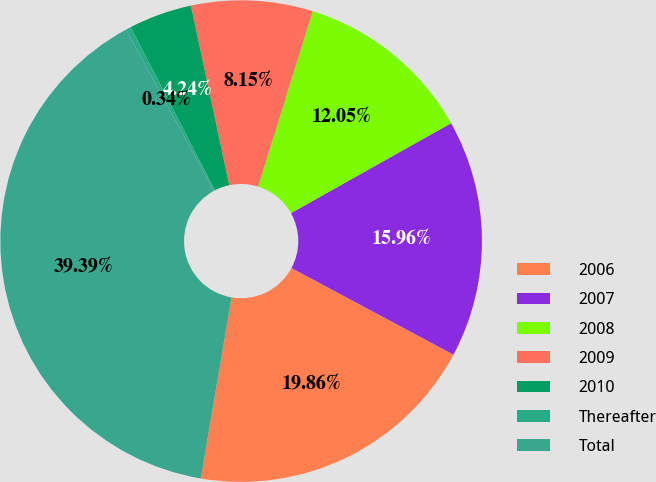Convert chart to OTSL. <chart><loc_0><loc_0><loc_500><loc_500><pie_chart><fcel>2006<fcel>2007<fcel>2008<fcel>2009<fcel>2010<fcel>Thereafter<fcel>Total<nl><fcel>19.86%<fcel>15.96%<fcel>12.05%<fcel>8.15%<fcel>4.24%<fcel>0.34%<fcel>39.39%<nl></chart> 